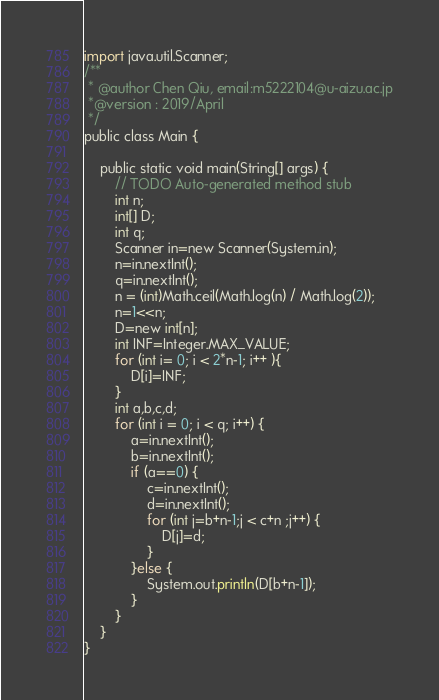<code> <loc_0><loc_0><loc_500><loc_500><_Go_>import java.util.Scanner;
/**
 * @author Chen Qiu, email:m5222104@u-aizu.ac.jp
 *@version : 2019/April
 */
public class Main {

	public static void main(String[] args) {
		// TODO Auto-generated method stub
		int n;
		int[] D;
		int q;
		Scanner in=new Scanner(System.in);
		n=in.nextInt();
		q=in.nextInt();
        n = (int)Math.ceil(Math.log(n) / Math.log(2));
        n=1<<n;
		D=new int[n];
		int INF=Integer.MAX_VALUE;
		for (int i= 0; i < 2*n-1; i++ ){
			D[i]=INF;
		}
		int a,b,c,d;
		for (int i = 0; i < q; i++) {
			a=in.nextInt();
			b=in.nextInt();
			if (a==0) {
				c=in.nextInt();
				d=in.nextInt();
				for (int j=b+n-1;j < c+n ;j++) {
					D[j]=d;
				}
			}else {
				System.out.println(D[b+n-1]);
			}
		}
	}
}

</code> 